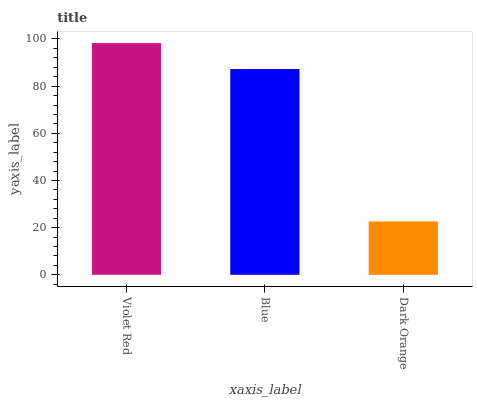Is Dark Orange the minimum?
Answer yes or no. Yes. Is Violet Red the maximum?
Answer yes or no. Yes. Is Blue the minimum?
Answer yes or no. No. Is Blue the maximum?
Answer yes or no. No. Is Violet Red greater than Blue?
Answer yes or no. Yes. Is Blue less than Violet Red?
Answer yes or no. Yes. Is Blue greater than Violet Red?
Answer yes or no. No. Is Violet Red less than Blue?
Answer yes or no. No. Is Blue the high median?
Answer yes or no. Yes. Is Blue the low median?
Answer yes or no. Yes. Is Violet Red the high median?
Answer yes or no. No. Is Violet Red the low median?
Answer yes or no. No. 